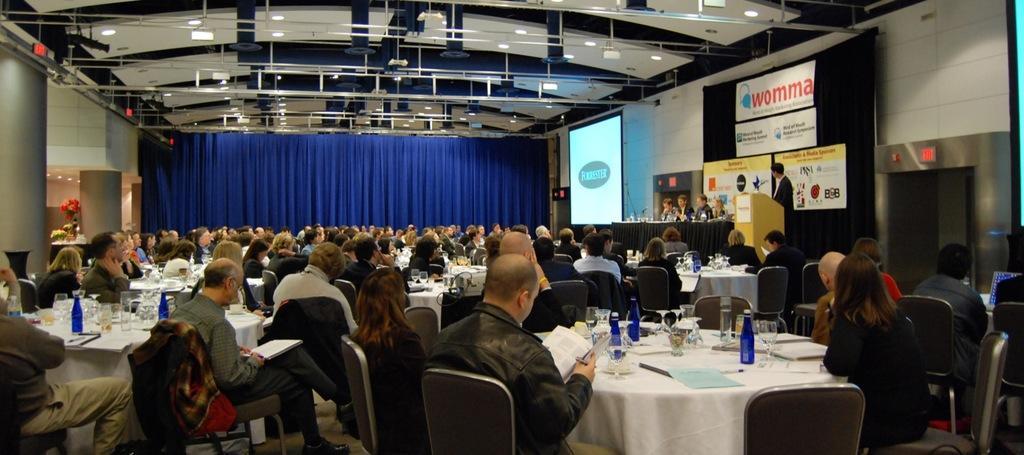Can you describe this image briefly? in this image I see people are sitting on chairs and there are tables in front of them on which there are glasses, bottles and other things on it, I can also see a man over here who is standing in front of a podium. In the background I see the blue color curtain and lights on the ceiling and I can also see a screen over here and few banners over here. 